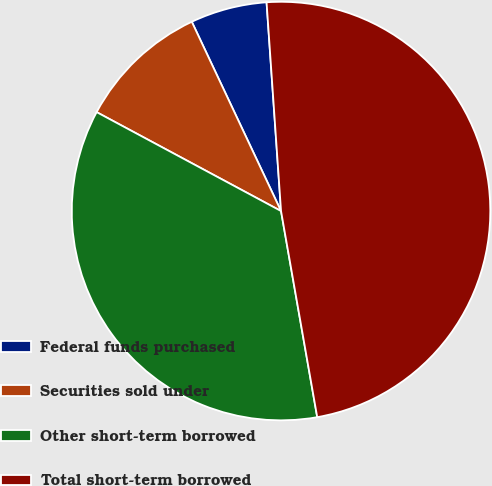<chart> <loc_0><loc_0><loc_500><loc_500><pie_chart><fcel>Federal funds purchased<fcel>Securities sold under<fcel>Other short-term borrowed<fcel>Total short-term borrowed<nl><fcel>5.91%<fcel>10.15%<fcel>35.6%<fcel>48.33%<nl></chart> 